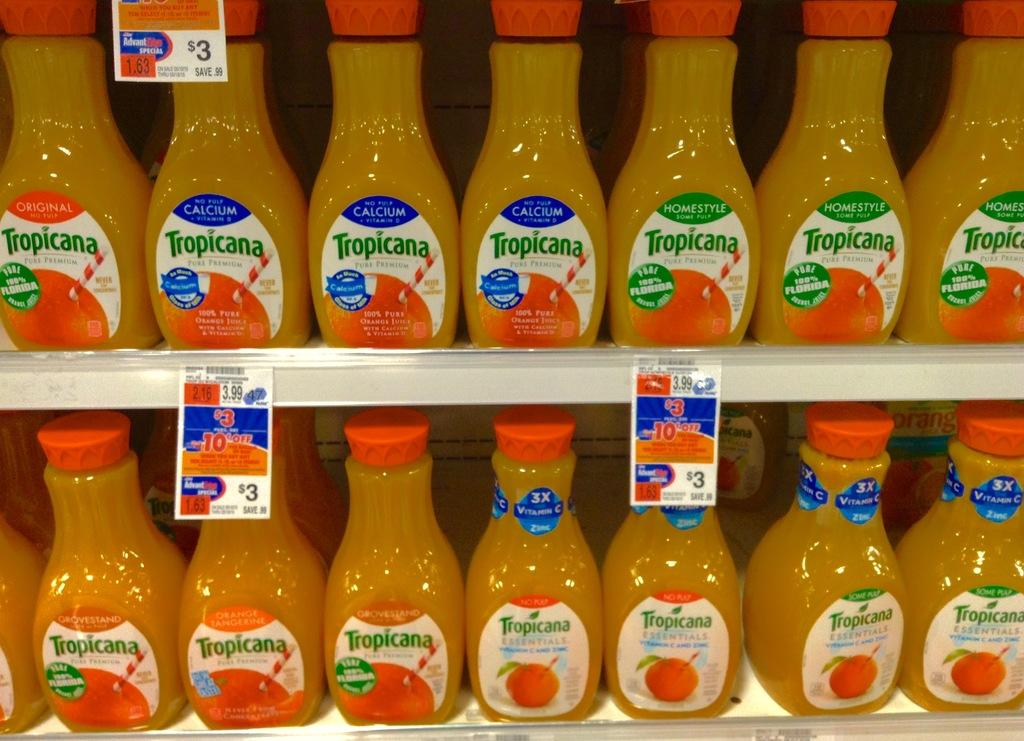<image>
Present a compact description of the photo's key features. Two rows of bottles of Tropicana orange juice. 